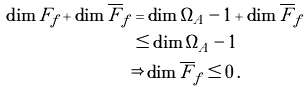Convert formula to latex. <formula><loc_0><loc_0><loc_500><loc_500>\dim F _ { f } + \dim \overline { F } _ { f } & = \dim \Omega _ { A } - 1 + \dim \overline { F } _ { f } \\ & \leq \dim \Omega _ { A } - 1 \\ & \Rightarrow \dim \overline { F } _ { f } \leq 0 \, .</formula> 